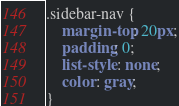Convert code to text. <code><loc_0><loc_0><loc_500><loc_500><_CSS_>.sidebar-nav {
    margin-top: 20px;
    padding: 0;
    list-style: none;
    color: gray;
}</code> 